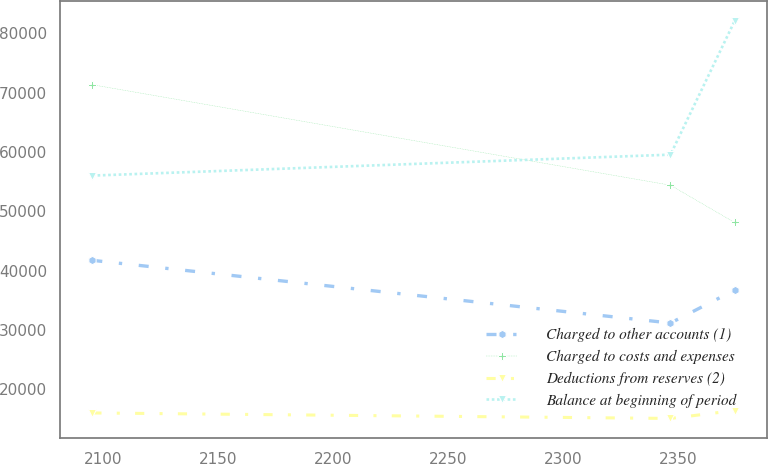<chart> <loc_0><loc_0><loc_500><loc_500><line_chart><ecel><fcel>Charged to other accounts (1)<fcel>Charged to costs and expenses<fcel>Deductions from reserves (2)<fcel>Balance at beginning of period<nl><fcel>2095.24<fcel>41737.8<fcel>71331.9<fcel>16017.2<fcel>56018.4<nl><fcel>2346.73<fcel>31172.2<fcel>54398<fcel>15088.9<fcel>59546.8<nl><fcel>2374.58<fcel>36702.7<fcel>48120.7<fcel>16420.2<fcel>82027.8<nl></chart> 